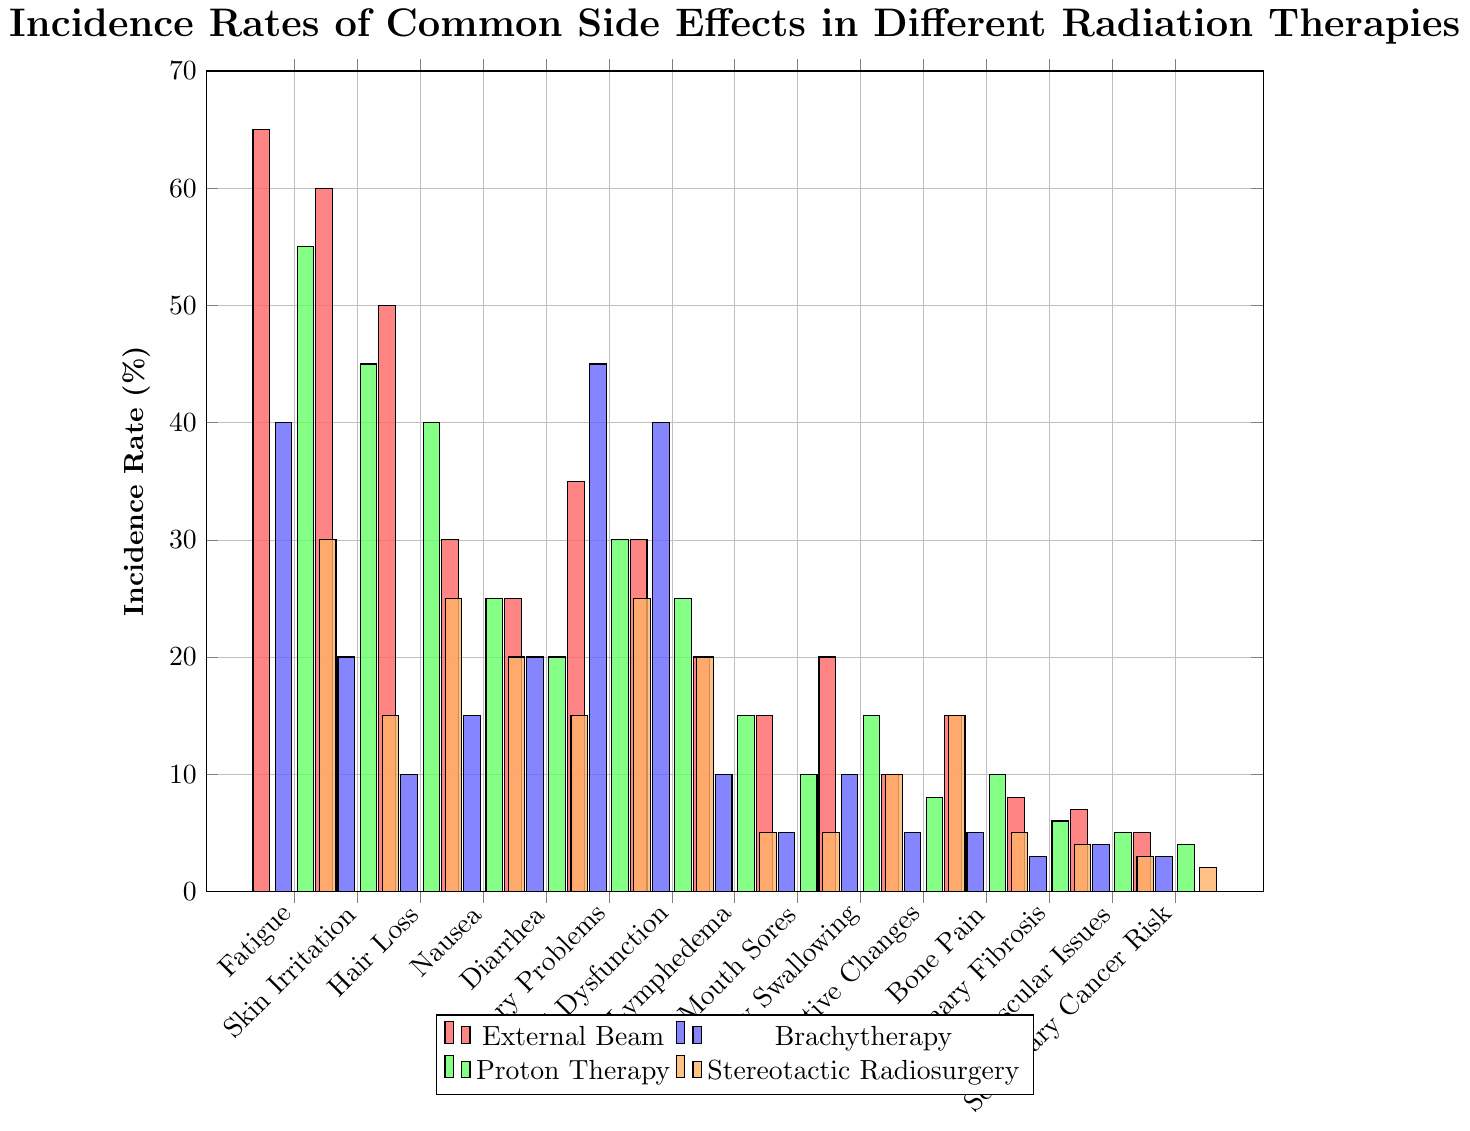Which side effect has the highest incidence rate in External Beam radiation therapy? The tallest bar in the "External Beam" series (red) indicates the side effect with the highest incidence rate. The tallest bar corresponds to "Fatigue" with an incidence rate of 65%.
Answer: Fatigue Which forms of radiation therapy show an incidence rate of 5% for Mouth Sores? Look for the bars corresponding to "Mouth Sores" that reach the 5% mark. Both "Brachytherapy" (blue) and "Stereotactic Radiosurgery" (orange) have bars reaching the 5% mark.
Answer: Brachytherapy, Stereotactic Radiosurgery Compare the incidence rates of Cognitive Changes across all radiation therapies. Which therapy shows the highest rate, and what is the value? Find the bars corresponding to "Cognitive Changes" for all therapies. The highest bar among them is for "Stereotactic Radiosurgery" (orange), with a rate of 15%.
Answer: Stereotactic Radiosurgery, 15% What is the average incidence rate of Secondary Cancer Risk across all types of radiation therapies? Sum the incidence rates for Secondary Cancer Risk for all therapies (5+3+4+2) and divide by the number of therapies (4). So, average = (5 + 3 + 4 + 2) / 4 = 3.5.
Answer: 3.5 Which side effect has the lowest incidence rate in Proton Therapy, and what is the value? Identify the shortest bar in the "Proton Therapy" series (green). The shortest bar corresponds to "Secondary Cancer Risk" with a value of 4%.
Answer: Secondary Cancer Risk, 4% Is the incidence rate of Hair Loss higher in External Beam or Proton Therapy? By how much? Compare the heights of the bars for "Hair Loss" in External Beam (50%) and Proton Therapy (40%). The rate in External Beam is higher by 10%.
Answer: External Beam, 10% Which side effects show incidence rates greater than 50% in any type of radiation therapy? Identify bars with heights exceeding 50%. "Fatigue" in External Beam (65%) and Proton Therapy (55%); "Skin Irritation" in External Beam (60%); and "Urinary Problems" in Brachytherapy (45%).
Answer: Fatigue, Skin Irritation If considering only External Beam and Stereotactic Radiosurgery, which side effect shows the greatest difference in incidence rates, and what is the difference? Calculate the difference in incidence rates for each side effect between External Beam and Stereotactic Radiosurgery. The greatest difference is for "Skin Irritation" (60%-15% = 45%).
Answer: Skin Irritation, 45% Between Brachytherapy and Proton Therapy, which treatment has a higher incidence rate for Diarrhea, and by how much? Compare the bars for "Diarrhea" in Brachytherapy (20%) and Proton Therapy (20%) to find they are equal.
Answer: Neither, 0% 